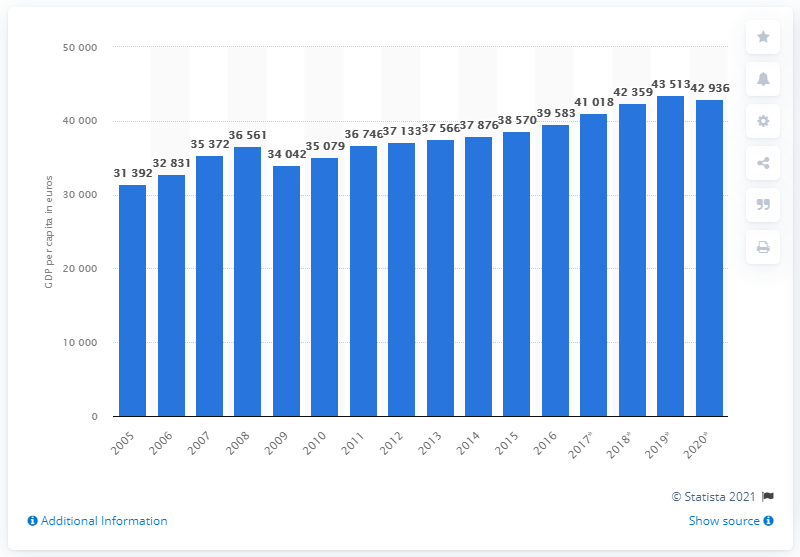Outline some significant characteristics in this image. In 2011, Finland's Gross Domestic Product (GDP) had returned to the level it was at prior to the financial crisis. 